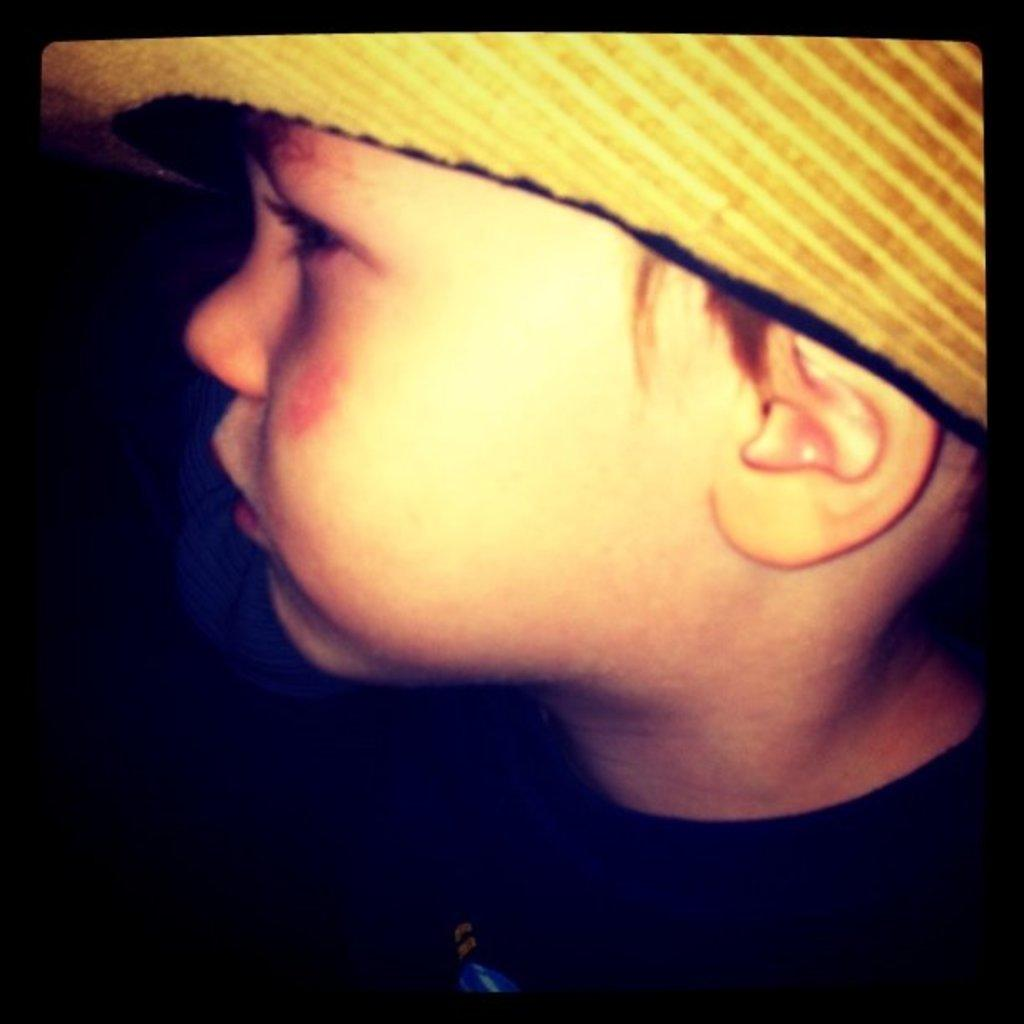What is the main subject of the image? The main subject of the image is a boy. Can you describe the boy's attire in the image? The boy is wearing a hat in the image. What type of horn can be seen on the boy's head in the image? There is no horn present on the boy's head in the image. 